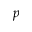<formula> <loc_0><loc_0><loc_500><loc_500>p</formula> 